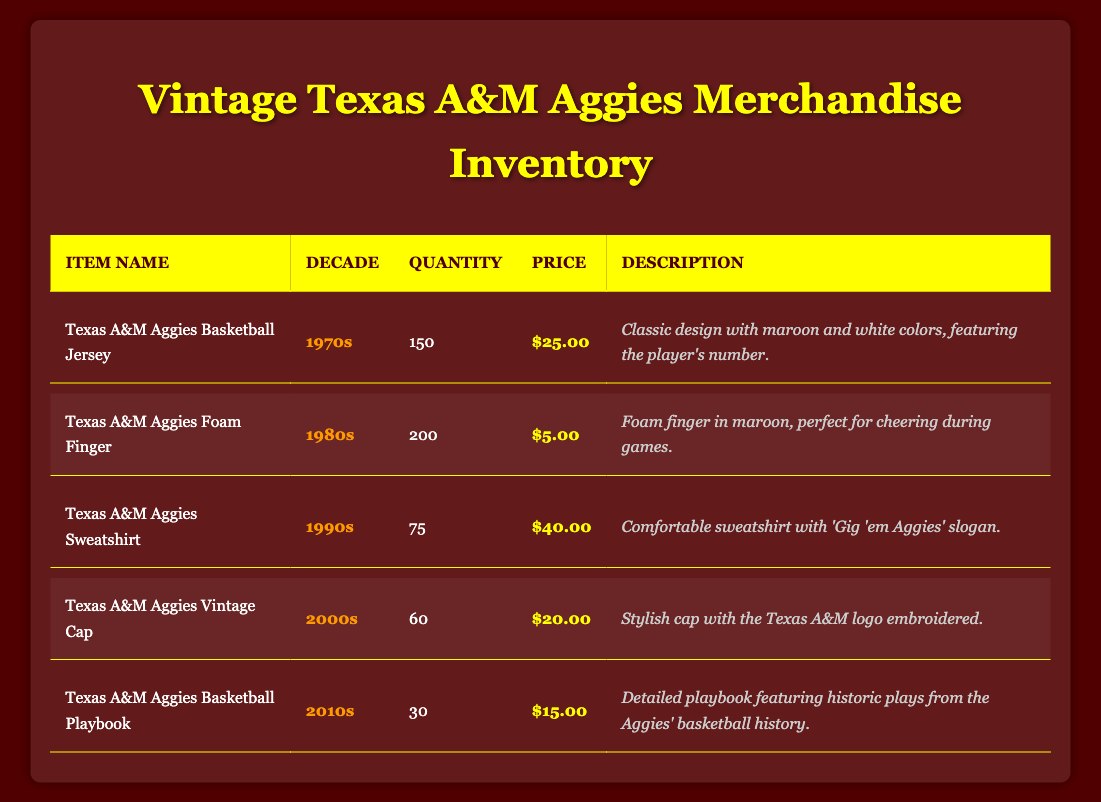What item has the highest quantity available? By reviewing the "Quantity" column for all items, it's clear that the Texas A&M Aggies Foam Finger has the highest quantity available, which is 200.
Answer: Texas A&M Aggies Foam Finger What decade does the Texas A&M Aggies Sweatshirt belong to? The Sweatshirt is listed in the "Decade" column, showing that it belongs to the 1990s.
Answer: 1990s How much does the Texas A&M Aggies Basketball Jersey cost? Looking at the "Price" column for the Basketball Jersey, it is priced at $25.00.
Answer: $25.00 What is the total quantity of vintage items available from the 2000s? In the 2000s, only the Texas A&M Aggies Vintage Cap is available with a quantity of 60. Therefore, the total quantity from this decade is 60.
Answer: 60 Is there a Texas A&M Aggies Basketball Playbook available from the 1970s? Checking the "Decade" for the Texas A&M Aggies Basketball Playbook reveals it belongs to the 2010s, confirming that there is no such item available from the 1970s.
Answer: No What is the average price of the items from the 1990s and 2000s combined? The prices are $40.00 for the Sweatshirt and $20.00 for the Cap. Adding these gives $40 + $20 = $60. Dividing by the two items gives an average price of $30.00.
Answer: $30.00 Is the quantity of Basketball jerseys greater than the sum of Foam Fingers and Vintage Caps? The Basketball Jersey has 150, while Foam Fingers (200) and Vintage Caps (60) sum to 260. Since 150 is not greater than 260, the answer is no.
Answer: No Which item has the lowest quantity available, and what is its price? By examining the "Quantity" column, the Texas A&M Aggies Basketball Playbook has the lowest available quantity of 30, and its price is $15.00.
Answer: Texas A&M Aggies Basketball Playbook, $15.00 